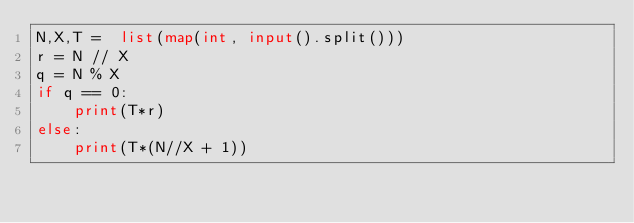<code> <loc_0><loc_0><loc_500><loc_500><_Python_>N,X,T =  list(map(int, input().split()))
r = N // X
q = N % X
if q == 0:
    print(T*r)
else:
    print(T*(N//X + 1)) 
</code> 